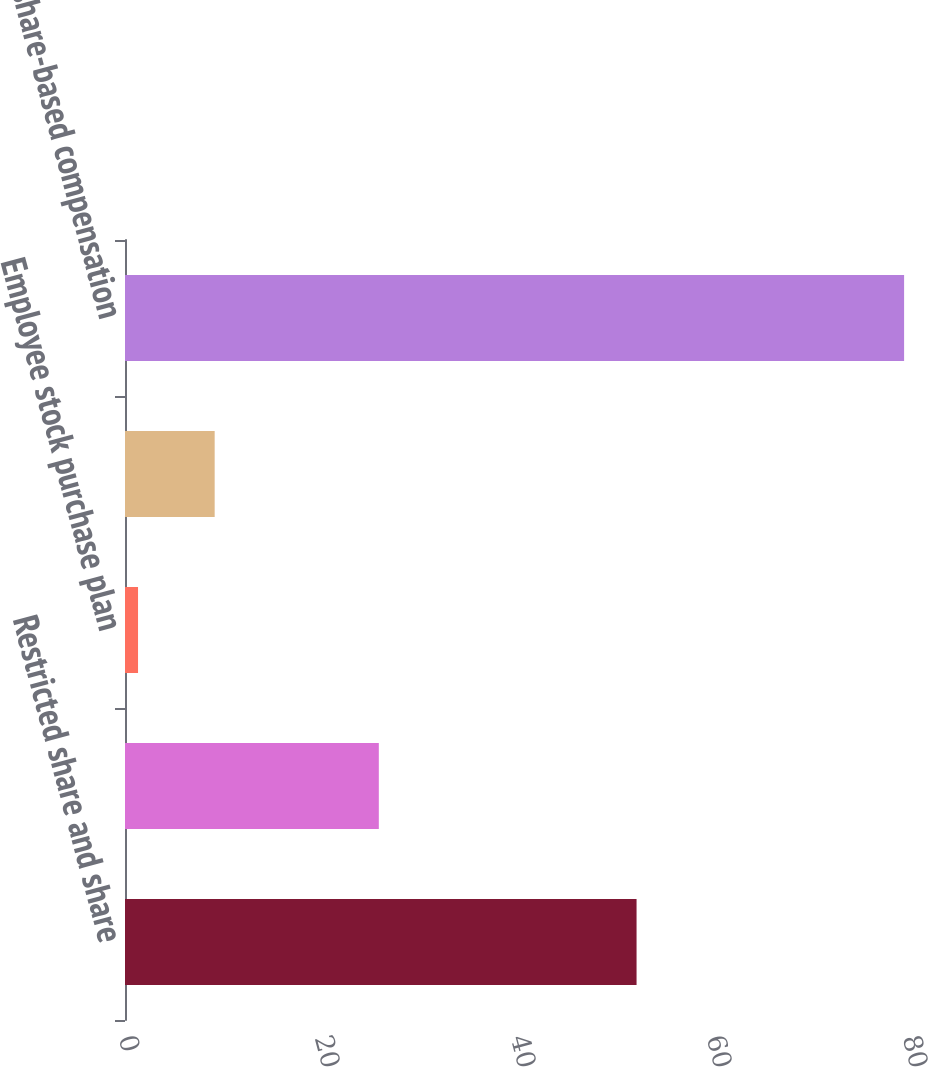Convert chart to OTSL. <chart><loc_0><loc_0><loc_500><loc_500><bar_chart><fcel>Restricted share and share<fcel>Employee stock option expense<fcel>Employee stock purchase plan<fcel>Stock appreciation<fcel>Total share-based compensation<nl><fcel>52.2<fcel>25.9<fcel>1.33<fcel>9.15<fcel>79.5<nl></chart> 